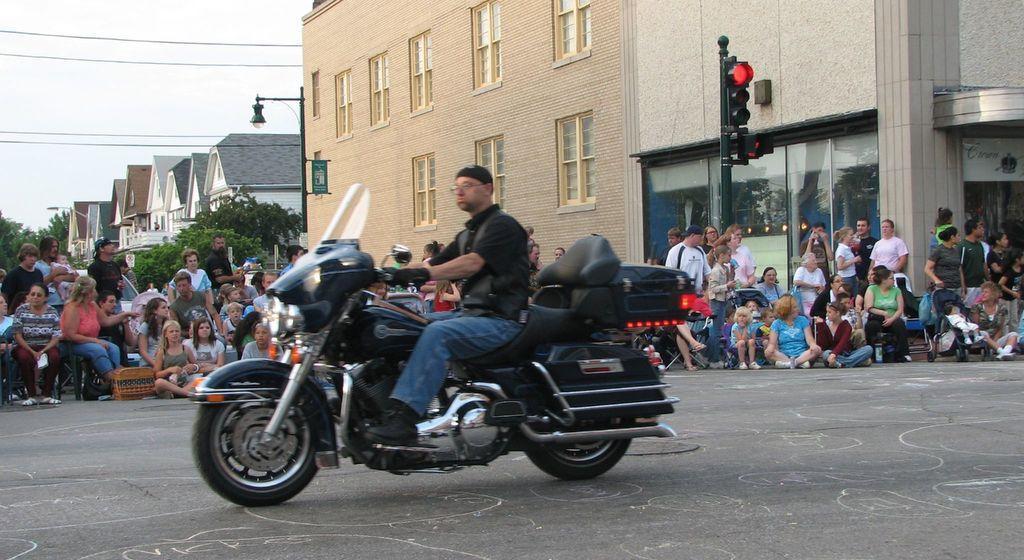Describe this image in one or two sentences. This picture describes about group of people, a man riding a bike and other people are seated in the middle of the road in the background we can find traffic signal and some sign boards, and we can find buildings and trees. 